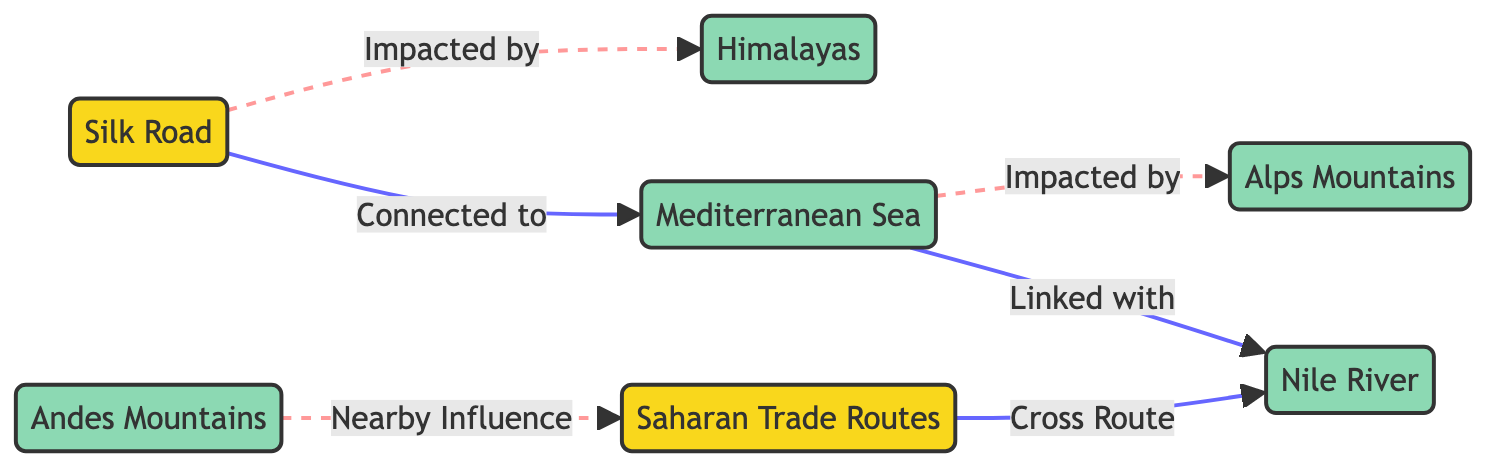What are the two main trade routes depicted in the diagram? The diagram outlines two primary trade routes: the Silk Road and the Saharan Trade Routes. These routes are explicitly labeled in the diagram, making them easily identifiable.
Answer: Silk Road, Saharan Trade Routes Which mountain range impacts the Silk Road? The diagram shows that the Himalayan mountain range is depicted as impacting the Silk Road through a dotted line that signifies influence. This indicates that the geographical feature plays a significant role in shaping the trade route.
Answer: Himalayas How many geographic features are represented in the diagram? By counting the nodes labeled as geographic features, which include the Himalayas, Mediterranean Sea, Andes Mountains, Alps Mountains, and Nile River, we find there are five distinct geographic features illustrated in the diagram.
Answer: 5 What sea is the Mediterranean trade route connected to? The diagram illustrates a direct connection between the Mediterranean Sea and the Silk Road, indicated by a solid line. This establishes the Mediterranean as a linked body of water to the trade route shown.
Answer: Silk Road Which mountain range is associated with the Mediterranean Sea? The diagram shows a dashed line from the Mediterranean Sea to the Alps Mountains, which denotes the influence of the Alps on the Mediterranean trade route. This connection signifies that the geographic feature impacts trade activities in that region.
Answer: Alps Mountains Which two bodies of water have a direct connection in the diagram? The diagram indicates that the Mediterranean Sea is directly connected to the Nile River through a solid line, reflecting trade or geographic links between these two water bodies.
Answer: Mediterranean Sea, Nile River What is the relationship between the Andes and Saharan Trade Routes? The diagram depicts a nearby influence of the Andes Mountains on the Saharan Trade Routes, represented by a dashed line. This indicates that the Andes may not directly affect trade but are in proximity to the Saharan routes.
Answer: Nearby Influence How many connections does the Nile River have in the diagram? By analyzing the diagram, we see that the Nile River has two connections: one to the Mediterranean Sea and another to the Saharan Trade Routes, showcasing its role in interlinking these routes.
Answer: 2 